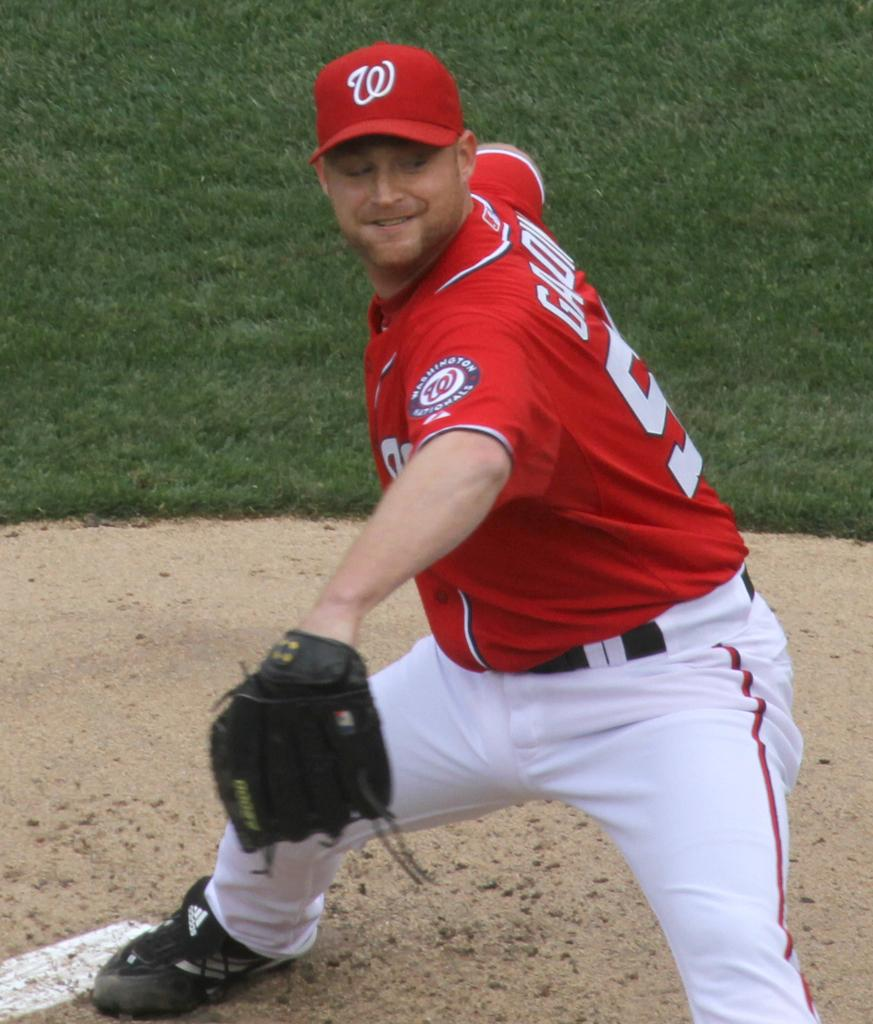Provide a one-sentence caption for the provided image. A pitcher for the Washington National throws a pitch during a baseball game. 